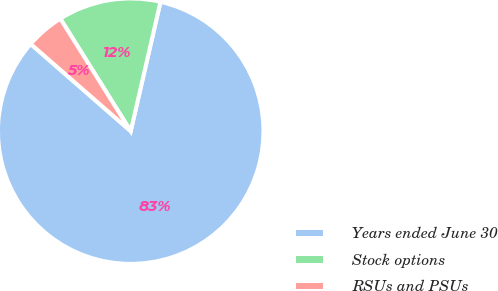Convert chart to OTSL. <chart><loc_0><loc_0><loc_500><loc_500><pie_chart><fcel>Years ended June 30<fcel>Stock options<fcel>RSUs and PSUs<nl><fcel>82.81%<fcel>12.5%<fcel>4.69%<nl></chart> 